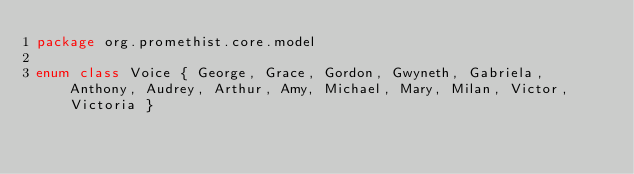Convert code to text. <code><loc_0><loc_0><loc_500><loc_500><_Kotlin_>package org.promethist.core.model

enum class Voice { George, Grace, Gordon, Gwyneth, Gabriela, Anthony, Audrey, Arthur, Amy, Michael, Mary, Milan, Victor, Victoria }</code> 